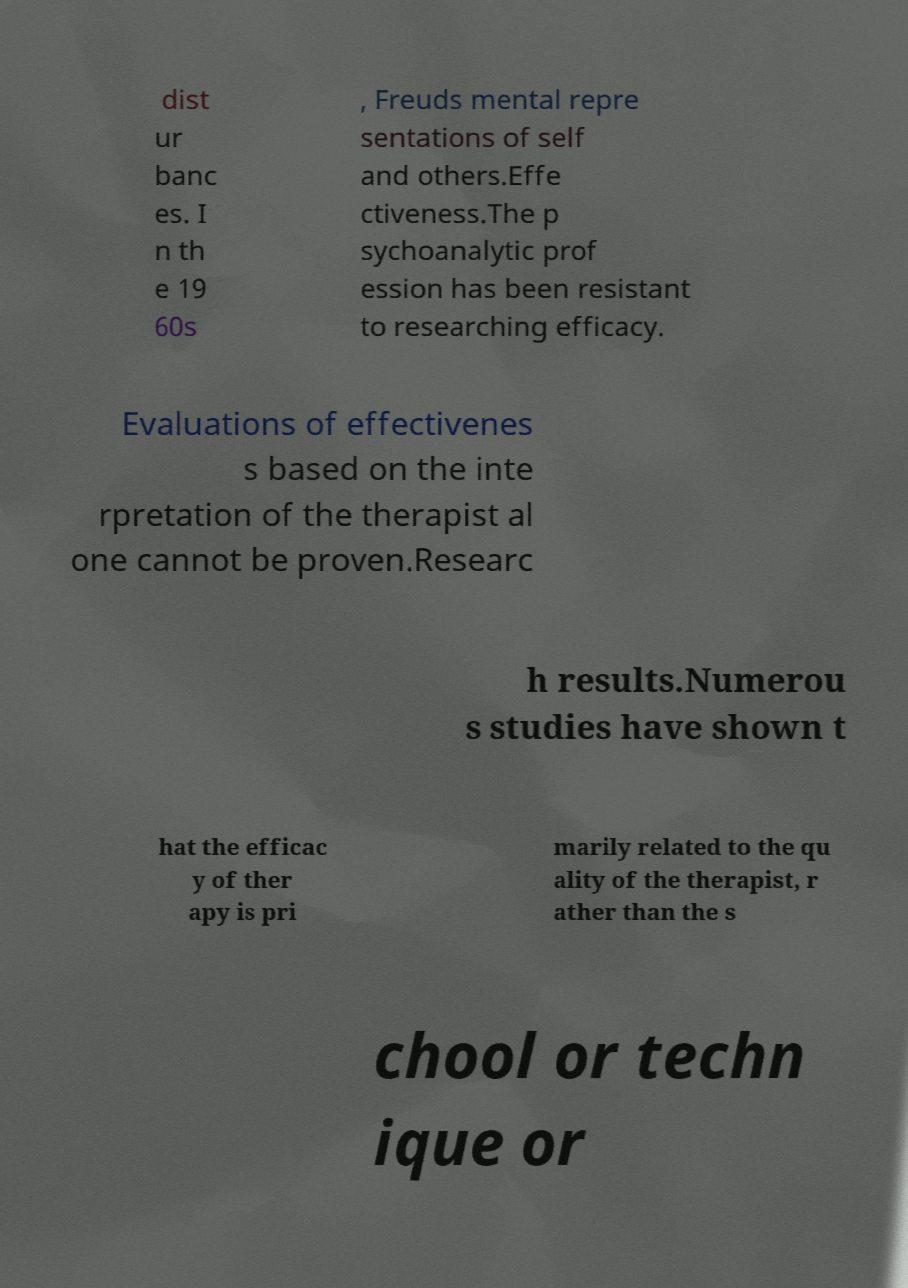Can you accurately transcribe the text from the provided image for me? dist ur banc es. I n th e 19 60s , Freuds mental repre sentations of self and others.Effe ctiveness.The p sychoanalytic prof ession has been resistant to researching efficacy. Evaluations of effectivenes s based on the inte rpretation of the therapist al one cannot be proven.Researc h results.Numerou s studies have shown t hat the efficac y of ther apy is pri marily related to the qu ality of the therapist, r ather than the s chool or techn ique or 